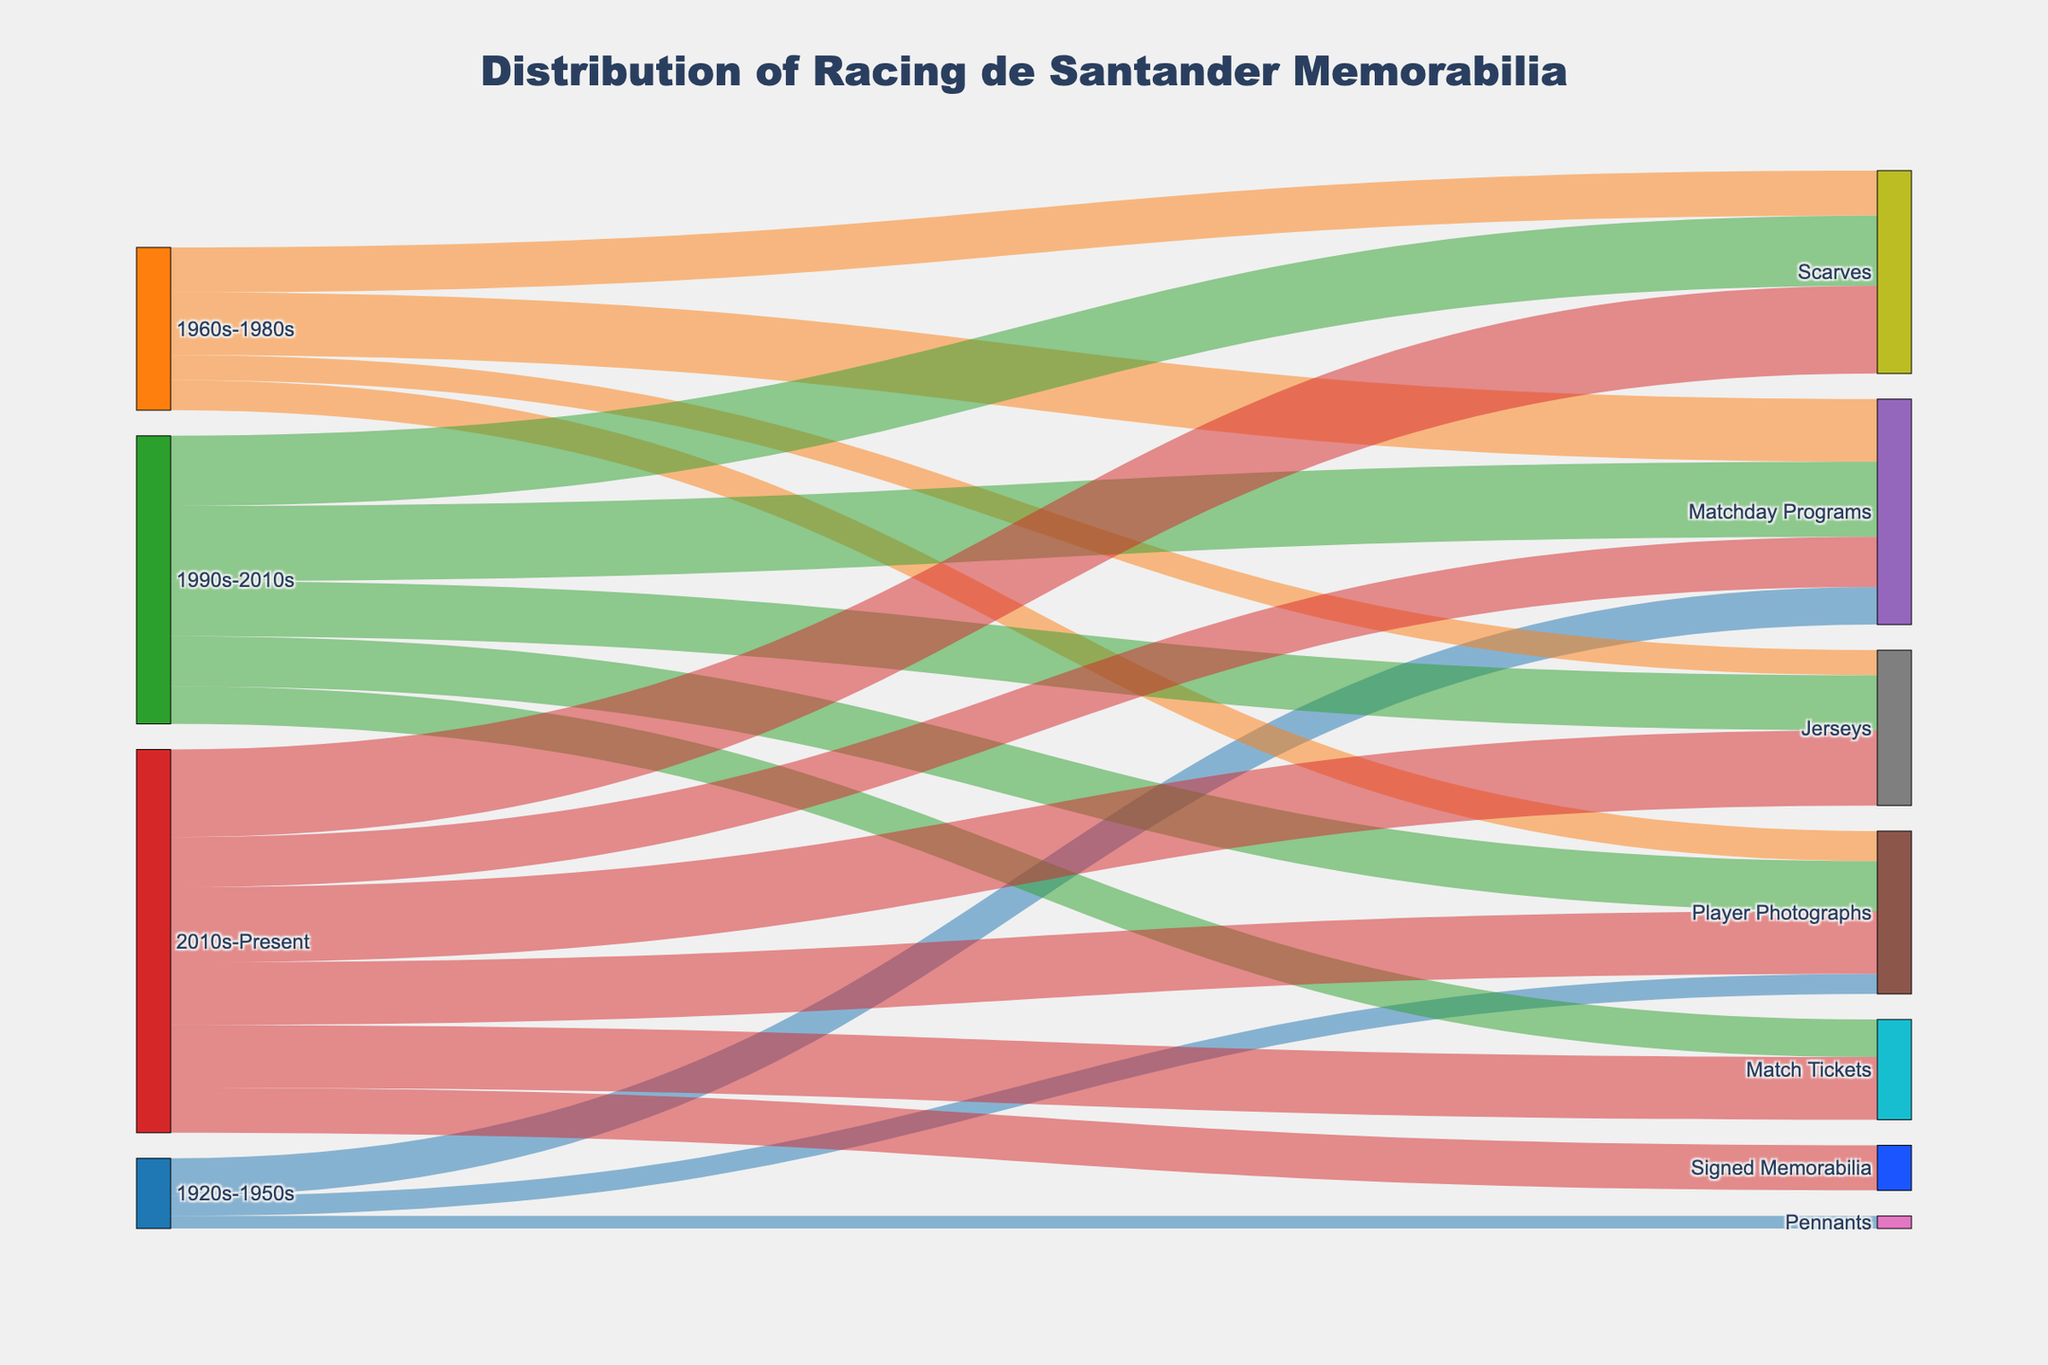Which era has the most memorabilia items? To find the era with the most items, sum all the values for each era. The 2010s-Present era has the highest total (20 + 25 + 30 + 35 + 25 + 18 = 153).
Answer: 2010s-Present Which item type in the 1960s-1980s category has the least number of memorabilia items? Look at the values associated with the 1960s-1980s category and find the minimum. Jerseys have the least with 10 items.
Answer: Jerseys What is the total number of Matchday Programs across all eras? Sum the values for Matchday Programs from each era (15 + 25 + 30 + 20 = 90).
Answer: 90 How does the popularity of Jerseys change from the 1960s-1980s era to the 2010s-Present era? Compare the values of Jerseys in both eras. In the 1960s-1980s, it is 10, and in the 2010s-Present, it is 30. The popularity increases by 20.
Answer: The popularity increases Which era contributes the most to the category 'Player Photographs'? Sum the values of Player Photographs for each era and compare. The 2010s-Present era has the highest value of 25.
Answer: 2010s-Present Are there any item types that only appear in the most recent era (2010s-Present)? Check if any items are exclusively listed under 2010s-Present. "Signed Memorabilia" and "Match Tickets" are listed only here.
Answer: Signed Memorabilia Which item type saw the most growth from the 1990s-2010s to the 2010s-Present? Compare all item types between these two eras to find the one with the highest increase. Scarves increased from 28 to 35, which is a growth of 7.
Answer: Scarves What is the average number of memorabilia items produced per item type in the 1990s-2010s? Sum the values for all item types in the 1990s-2010s and divide by the number of item types (30 + 20 + 22 + 28 + 15 = 115; 115/5 = 23).
Answer: 23 Which item type appears in all eras? List all item types and check which ones are listed under every era. "Matchday Programs" and "Player Photographs" appear in all eras.
Answer: Matchday Programs, Player Photographs Between the 1920s-1950s era and the 1990s-2010s era, which one has more unique types of memorabilia? Count the different item types in each era. The 1920s-1950s has 3 types, and the 1990s-2010s has 5 types.
Answer: 1990s-2010s 